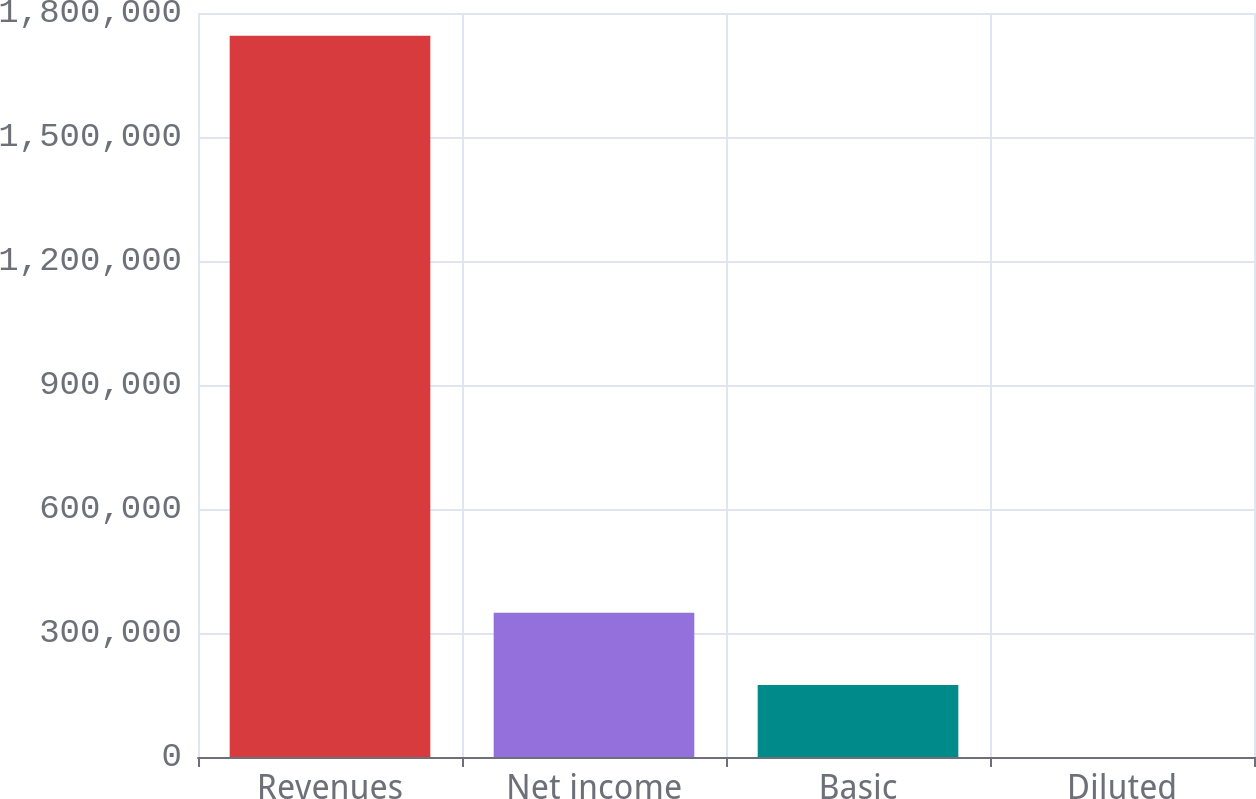Convert chart. <chart><loc_0><loc_0><loc_500><loc_500><bar_chart><fcel>Revenues<fcel>Net income<fcel>Basic<fcel>Diluted<nl><fcel>1.74468e+06<fcel>348937<fcel>174469<fcel>0.89<nl></chart> 